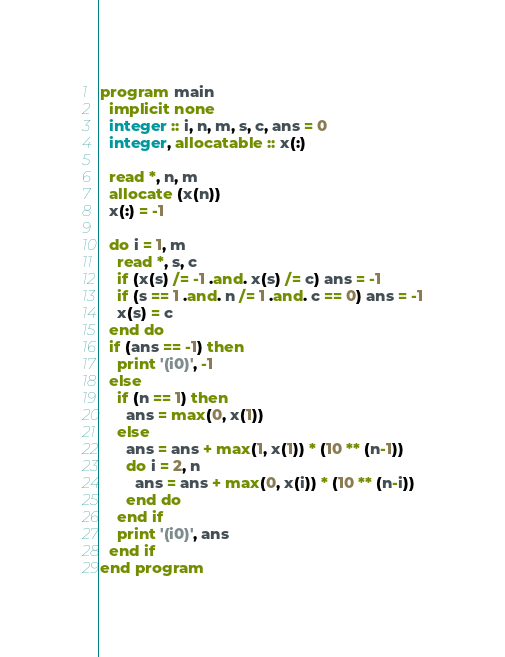Convert code to text. <code><loc_0><loc_0><loc_500><loc_500><_FORTRAN_>program main
  implicit none
  integer :: i, n, m, s, c, ans = 0
  integer, allocatable :: x(:)

  read *, n, m
  allocate (x(n))
  x(:) = -1

  do i = 1, m
    read *, s, c
    if (x(s) /= -1 .and. x(s) /= c) ans = -1
    if (s == 1 .and. n /= 1 .and. c == 0) ans = -1
    x(s) = c
  end do
  if (ans == -1) then
    print '(i0)', -1
  else
    if (n == 1) then
      ans = max(0, x(1))
    else
      ans = ans + max(1, x(1)) * (10 ** (n-1))
      do i = 2, n
        ans = ans + max(0, x(i)) * (10 ** (n-i))
      end do
    end if
    print '(i0)', ans
  end if
end program</code> 